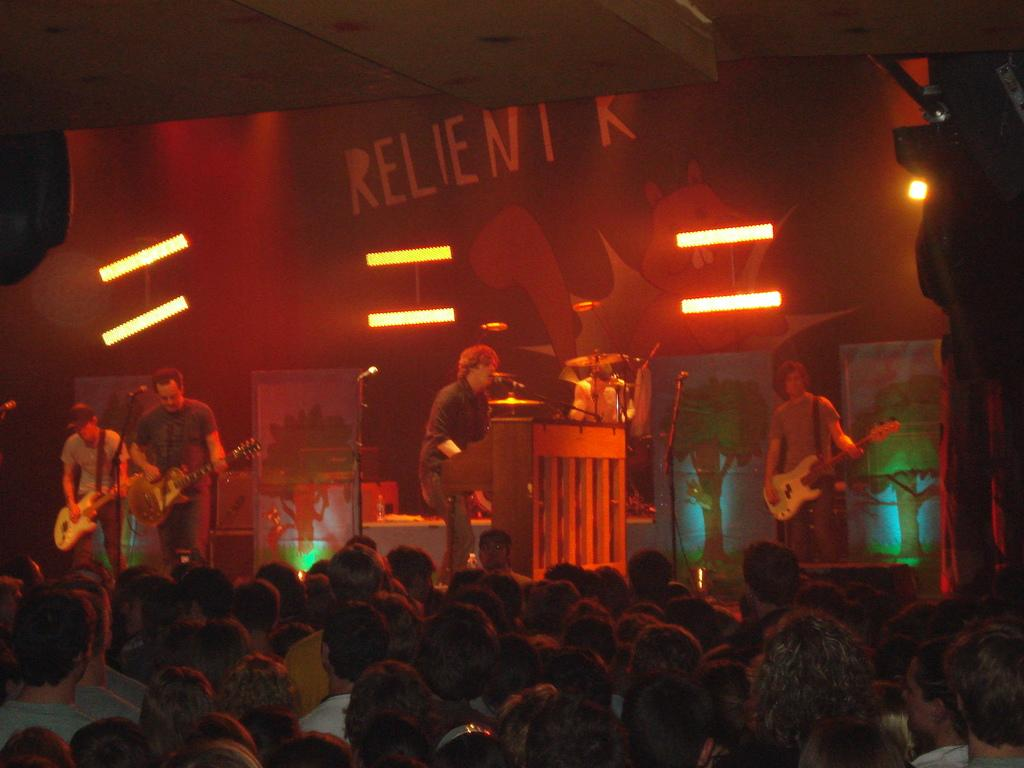What are the people in the image doing? The people in the image are performing on a stage. What instrument are the performers using? The performers are using a guitar. What can be seen in the background of the image? There is a crowd in the background of the image. What type of underwear is the guitarist wearing in the image? There is no information about the performers' underwear in the image, and therefore it cannot be determined. How many horses are visible in the image? There are no horses present in the image. 